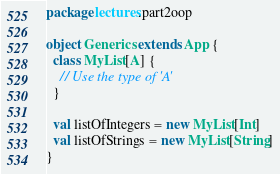Convert code to text. <code><loc_0><loc_0><loc_500><loc_500><_Scala_>package lectures.part2oop

object Generics extends App {
  class MyList[A] {
    // Use the type of 'A'
  }

  val listOfIntegers = new MyList[Int]
  val listOfStrings = new MyList[String]
}
</code> 